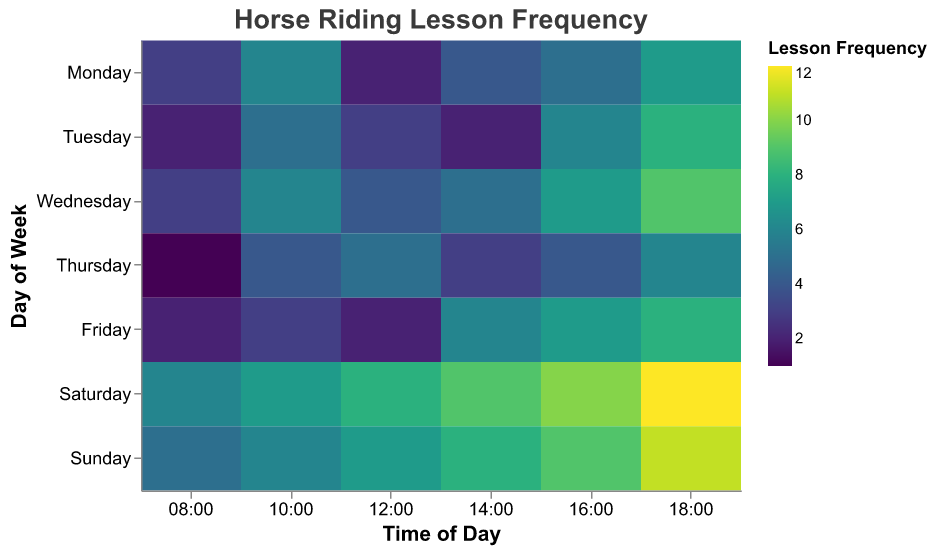Which day has the highest frequency of horse riding lessons at 18:00? Look at the data cells along the 18:00 time slot and compare the frequency values for each day. The highest value is 12 on Saturday.
Answer: Saturday What is the frequency of horse riding lessons on Wednesday at 12:00? Locate Wednesday on the y-axis and follow horizontally to the 12:00 time slot; the frequency value is 4.
Answer: 4 Which time of day has the lowest frequency of horse riding lessons on Thursday? Find Thursday on the y-axis and look at all the frequency values in this row. The lowest value is at 08:00, with a frequency of 1.
Answer: 08:00 What is the total number of horse riding lessons on Sunday? Sum the frequency values for every time period on Sunday: 5 + 6 + 7 + 8 + 9 + 11 = 46.
Answer: 46 Which time slot has the highest overall frequency of horse riding lessons across all days? Compare the total frequency across all days for each individual time slot. The time slot 18:00 generally has the highest frequencies, with Saturday at 12 topping the plot.
Answer: 18:00 Is the frequency of horse riding lessons higher on weekends compared to weekdays? Calculate the average frequency for weekends (Saturday and Sunday) and compare it with the average for weekdays (Monday to Friday). Weekends have higher average frequencies (with values from 12 to 11 on weekends, higher than the peak of 9 on weekdays).
Answer: Yes How does the frequency of horse riding lessons on Tuesday at 10:00 compare to Thursday at 10:00? Find the frequency values for Tuesday at 10:00 (5) and Thursday at 10:00 (4). Compare these values.
Answer: Tuesday's frequency is higher What is the average frequency of horse riding lessons on Saturday? Sum all frequency values for Saturday and divide by the number of time slots: (6 + 7 + 8 + 9 + 10 + 12) / 6 = 8.67.
Answer: 8.67 Is there any day where the frequency of horse riding lessons at 08:00 is greater than 5? Check the frequency values for each day at 08:00. Only Saturday has a value greater than 5, which is 6.
Answer: Yes On which days is the frequency of horse riding lessons at 14:00 equal? Compare the frequency values at 14:00 for each day; Monday, Tuesday, and Thursday each have a frequency of 4 at 14:00.
Answer: Monday, Tuesday, and Thursday 